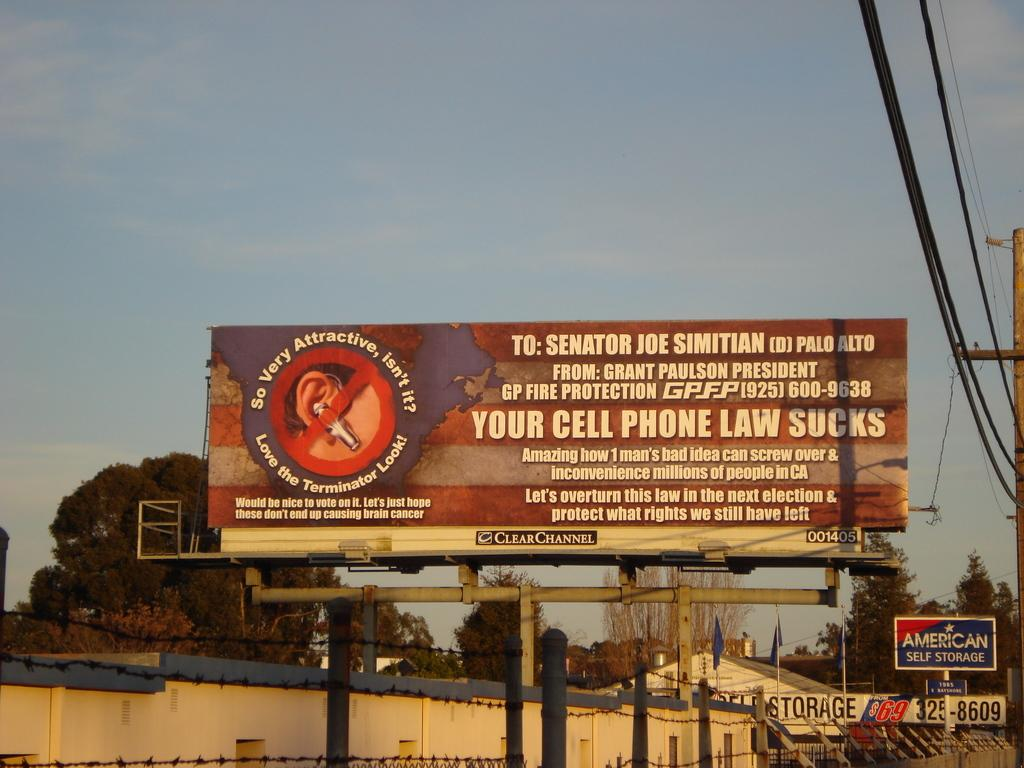<image>
Present a compact description of the photo's key features. ClearChannel border sign directed to Senator Joe Simitian. 